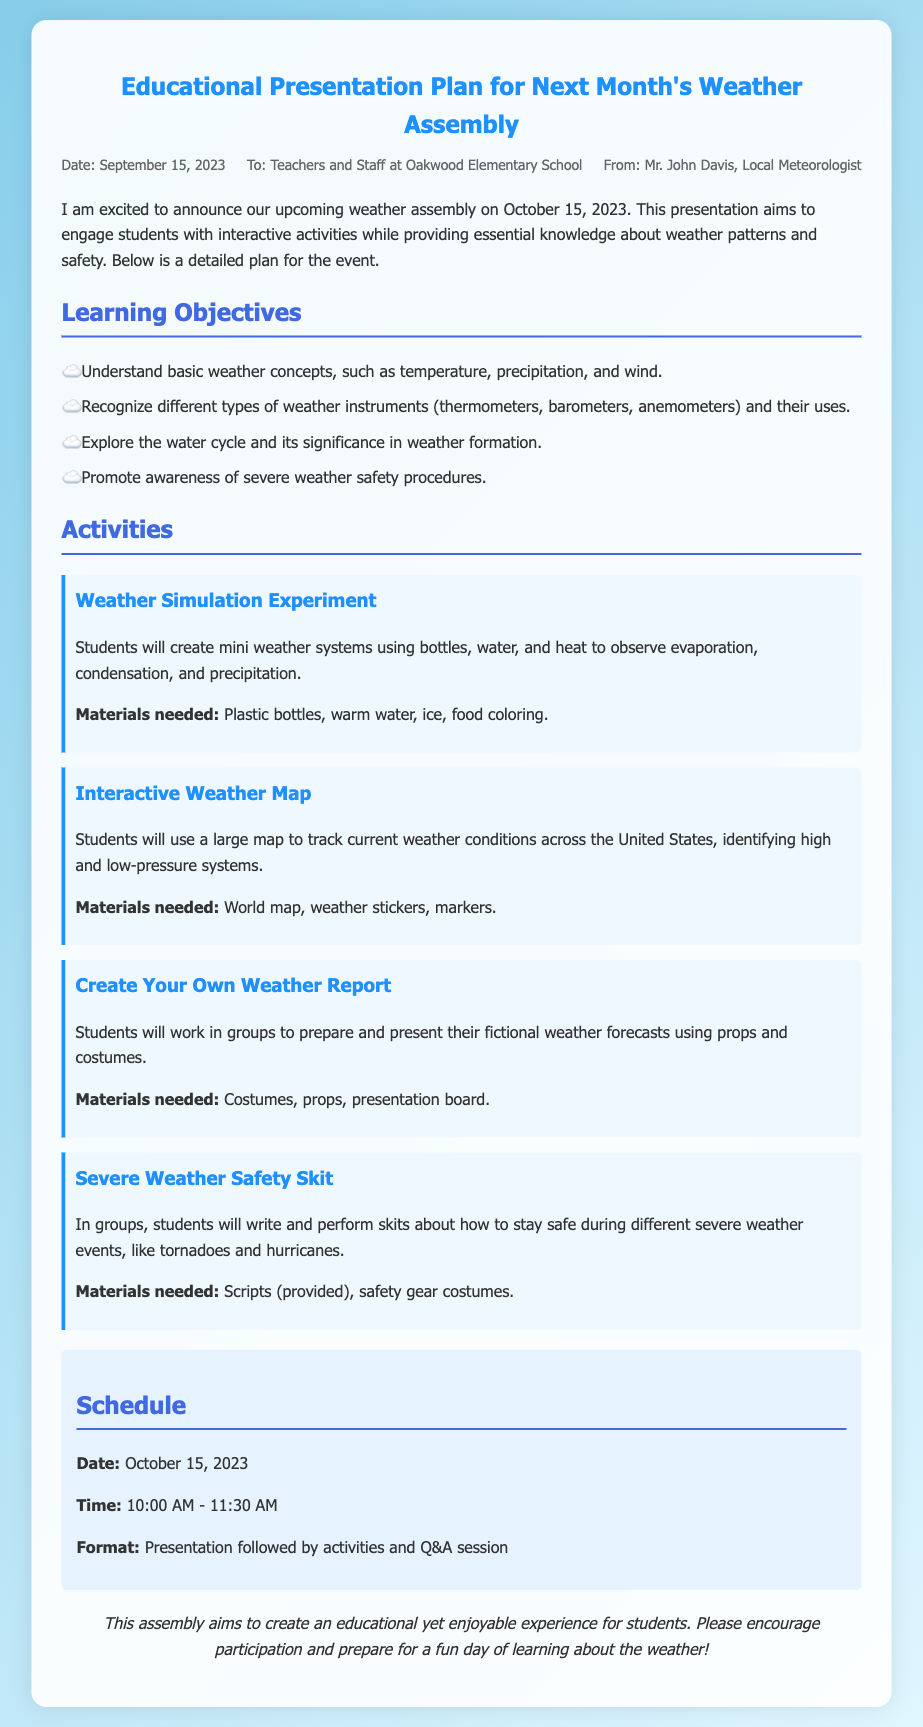What is the date of the weather assembly? The date of the weather assembly is explicitly stated in the document.
Answer: October 15, 2023 Who is the memo addressed to? The memo specifies the recipients at the beginning under "To:".
Answer: Teachers and Staff at Oakwood Elementary School What is one of the learning objectives? Learning objectives are listed in a bullet format in the document; one can be directly cited.
Answer: Understand basic weather concepts, such as temperature, precipitation, and wind What activity involves creating mini weather systems? This type of activity is described in detail, which allows for identification by its title.
Answer: Weather Simulation Experiment What time does the assembly start? The document provides a specific time for the event within the schedule section.
Answer: 10:00 AM How long is the weather assembly scheduled to last? The duration of the assembly can be calculated from the start and end times indicated in the schedule.
Answer: 1 hour 30 minutes What type of performance will students do for severe weather safety? This activity is detailed in the activities section with its aim and method.
Answer: Skits What type of materials are needed for the "Create Your Own Weather Report" activity? The materials required for each activity are listed in the document, making this information retrievable.
Answer: Costumes, props, presentation board 